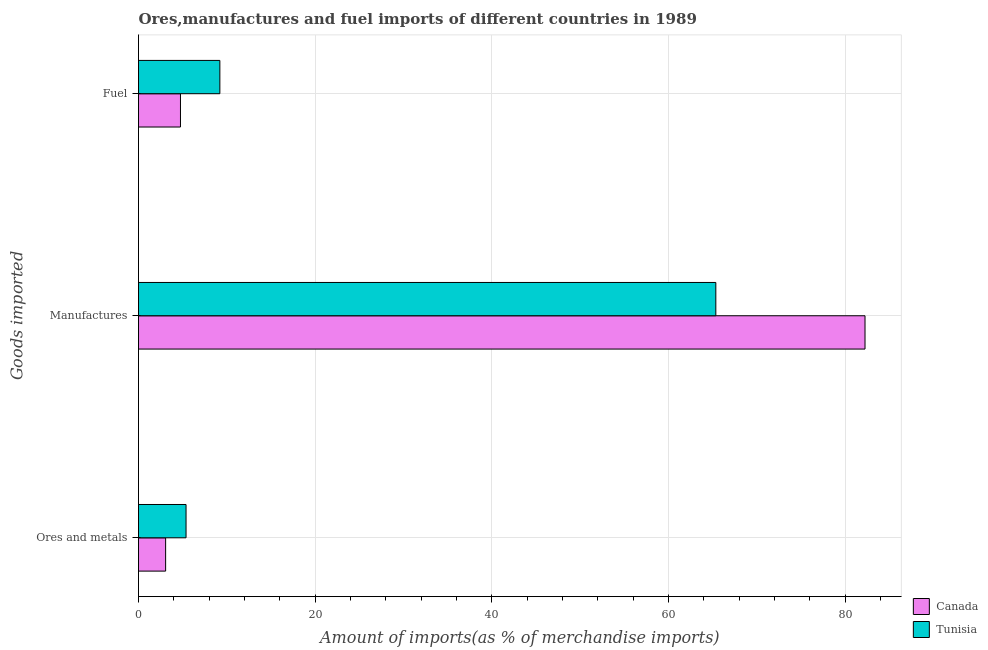How many groups of bars are there?
Ensure brevity in your answer.  3. Are the number of bars on each tick of the Y-axis equal?
Offer a terse response. Yes. What is the label of the 2nd group of bars from the top?
Ensure brevity in your answer.  Manufactures. What is the percentage of ores and metals imports in Tunisia?
Provide a short and direct response. 5.38. Across all countries, what is the maximum percentage of ores and metals imports?
Offer a terse response. 5.38. Across all countries, what is the minimum percentage of fuel imports?
Your response must be concise. 4.75. In which country was the percentage of manufactures imports maximum?
Your response must be concise. Canada. In which country was the percentage of fuel imports minimum?
Offer a very short reply. Canada. What is the total percentage of manufactures imports in the graph?
Your answer should be compact. 147.58. What is the difference between the percentage of ores and metals imports in Tunisia and that in Canada?
Keep it short and to the point. 2.31. What is the difference between the percentage of manufactures imports in Tunisia and the percentage of fuel imports in Canada?
Ensure brevity in your answer.  60.6. What is the average percentage of manufactures imports per country?
Your answer should be very brief. 73.79. What is the difference between the percentage of ores and metals imports and percentage of manufactures imports in Tunisia?
Offer a terse response. -59.97. In how many countries, is the percentage of ores and metals imports greater than 68 %?
Your response must be concise. 0. What is the ratio of the percentage of fuel imports in Tunisia to that in Canada?
Provide a succinct answer. 1.94. Is the percentage of fuel imports in Tunisia less than that in Canada?
Offer a terse response. No. What is the difference between the highest and the second highest percentage of ores and metals imports?
Make the answer very short. 2.31. What is the difference between the highest and the lowest percentage of ores and metals imports?
Ensure brevity in your answer.  2.31. In how many countries, is the percentage of ores and metals imports greater than the average percentage of ores and metals imports taken over all countries?
Ensure brevity in your answer.  1. What does the 1st bar from the top in Fuel represents?
Provide a short and direct response. Tunisia. What does the 2nd bar from the bottom in Fuel represents?
Keep it short and to the point. Tunisia. Is it the case that in every country, the sum of the percentage of ores and metals imports and percentage of manufactures imports is greater than the percentage of fuel imports?
Keep it short and to the point. Yes. How many bars are there?
Ensure brevity in your answer.  6. How many countries are there in the graph?
Make the answer very short. 2. Are the values on the major ticks of X-axis written in scientific E-notation?
Offer a very short reply. No. Does the graph contain any zero values?
Your response must be concise. No. Does the graph contain grids?
Provide a succinct answer. Yes. How many legend labels are there?
Your answer should be compact. 2. How are the legend labels stacked?
Ensure brevity in your answer.  Vertical. What is the title of the graph?
Offer a terse response. Ores,manufactures and fuel imports of different countries in 1989. What is the label or title of the X-axis?
Keep it short and to the point. Amount of imports(as % of merchandise imports). What is the label or title of the Y-axis?
Make the answer very short. Goods imported. What is the Amount of imports(as % of merchandise imports) of Canada in Ores and metals?
Keep it short and to the point. 3.07. What is the Amount of imports(as % of merchandise imports) of Tunisia in Ores and metals?
Ensure brevity in your answer.  5.38. What is the Amount of imports(as % of merchandise imports) of Canada in Manufactures?
Make the answer very short. 82.23. What is the Amount of imports(as % of merchandise imports) in Tunisia in Manufactures?
Provide a short and direct response. 65.35. What is the Amount of imports(as % of merchandise imports) of Canada in Fuel?
Offer a very short reply. 4.75. What is the Amount of imports(as % of merchandise imports) in Tunisia in Fuel?
Keep it short and to the point. 9.21. Across all Goods imported, what is the maximum Amount of imports(as % of merchandise imports) of Canada?
Offer a terse response. 82.23. Across all Goods imported, what is the maximum Amount of imports(as % of merchandise imports) in Tunisia?
Make the answer very short. 65.35. Across all Goods imported, what is the minimum Amount of imports(as % of merchandise imports) in Canada?
Your answer should be very brief. 3.07. Across all Goods imported, what is the minimum Amount of imports(as % of merchandise imports) of Tunisia?
Your response must be concise. 5.38. What is the total Amount of imports(as % of merchandise imports) of Canada in the graph?
Keep it short and to the point. 90.05. What is the total Amount of imports(as % of merchandise imports) of Tunisia in the graph?
Make the answer very short. 79.94. What is the difference between the Amount of imports(as % of merchandise imports) in Canada in Ores and metals and that in Manufactures?
Your answer should be compact. -79.16. What is the difference between the Amount of imports(as % of merchandise imports) in Tunisia in Ores and metals and that in Manufactures?
Make the answer very short. -59.97. What is the difference between the Amount of imports(as % of merchandise imports) of Canada in Ores and metals and that in Fuel?
Make the answer very short. -1.68. What is the difference between the Amount of imports(as % of merchandise imports) of Tunisia in Ores and metals and that in Fuel?
Your answer should be very brief. -3.83. What is the difference between the Amount of imports(as % of merchandise imports) in Canada in Manufactures and that in Fuel?
Your answer should be very brief. 77.48. What is the difference between the Amount of imports(as % of merchandise imports) of Tunisia in Manufactures and that in Fuel?
Your answer should be compact. 56.14. What is the difference between the Amount of imports(as % of merchandise imports) of Canada in Ores and metals and the Amount of imports(as % of merchandise imports) of Tunisia in Manufactures?
Offer a very short reply. -62.28. What is the difference between the Amount of imports(as % of merchandise imports) of Canada in Ores and metals and the Amount of imports(as % of merchandise imports) of Tunisia in Fuel?
Your response must be concise. -6.14. What is the difference between the Amount of imports(as % of merchandise imports) in Canada in Manufactures and the Amount of imports(as % of merchandise imports) in Tunisia in Fuel?
Your answer should be compact. 73.02. What is the average Amount of imports(as % of merchandise imports) in Canada per Goods imported?
Provide a short and direct response. 30.02. What is the average Amount of imports(as % of merchandise imports) of Tunisia per Goods imported?
Give a very brief answer. 26.65. What is the difference between the Amount of imports(as % of merchandise imports) of Canada and Amount of imports(as % of merchandise imports) of Tunisia in Ores and metals?
Provide a succinct answer. -2.31. What is the difference between the Amount of imports(as % of merchandise imports) of Canada and Amount of imports(as % of merchandise imports) of Tunisia in Manufactures?
Your answer should be very brief. 16.89. What is the difference between the Amount of imports(as % of merchandise imports) in Canada and Amount of imports(as % of merchandise imports) in Tunisia in Fuel?
Keep it short and to the point. -4.46. What is the ratio of the Amount of imports(as % of merchandise imports) of Canada in Ores and metals to that in Manufactures?
Your answer should be very brief. 0.04. What is the ratio of the Amount of imports(as % of merchandise imports) in Tunisia in Ores and metals to that in Manufactures?
Your response must be concise. 0.08. What is the ratio of the Amount of imports(as % of merchandise imports) of Canada in Ores and metals to that in Fuel?
Your answer should be very brief. 0.65. What is the ratio of the Amount of imports(as % of merchandise imports) in Tunisia in Ores and metals to that in Fuel?
Offer a very short reply. 0.58. What is the ratio of the Amount of imports(as % of merchandise imports) in Canada in Manufactures to that in Fuel?
Your answer should be compact. 17.31. What is the ratio of the Amount of imports(as % of merchandise imports) in Tunisia in Manufactures to that in Fuel?
Provide a short and direct response. 7.1. What is the difference between the highest and the second highest Amount of imports(as % of merchandise imports) in Canada?
Your answer should be very brief. 77.48. What is the difference between the highest and the second highest Amount of imports(as % of merchandise imports) in Tunisia?
Give a very brief answer. 56.14. What is the difference between the highest and the lowest Amount of imports(as % of merchandise imports) in Canada?
Ensure brevity in your answer.  79.16. What is the difference between the highest and the lowest Amount of imports(as % of merchandise imports) of Tunisia?
Offer a terse response. 59.97. 